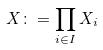Convert formula to latex. <formula><loc_0><loc_0><loc_500><loc_500>X \colon = \prod _ { i \in I } X _ { i }</formula> 